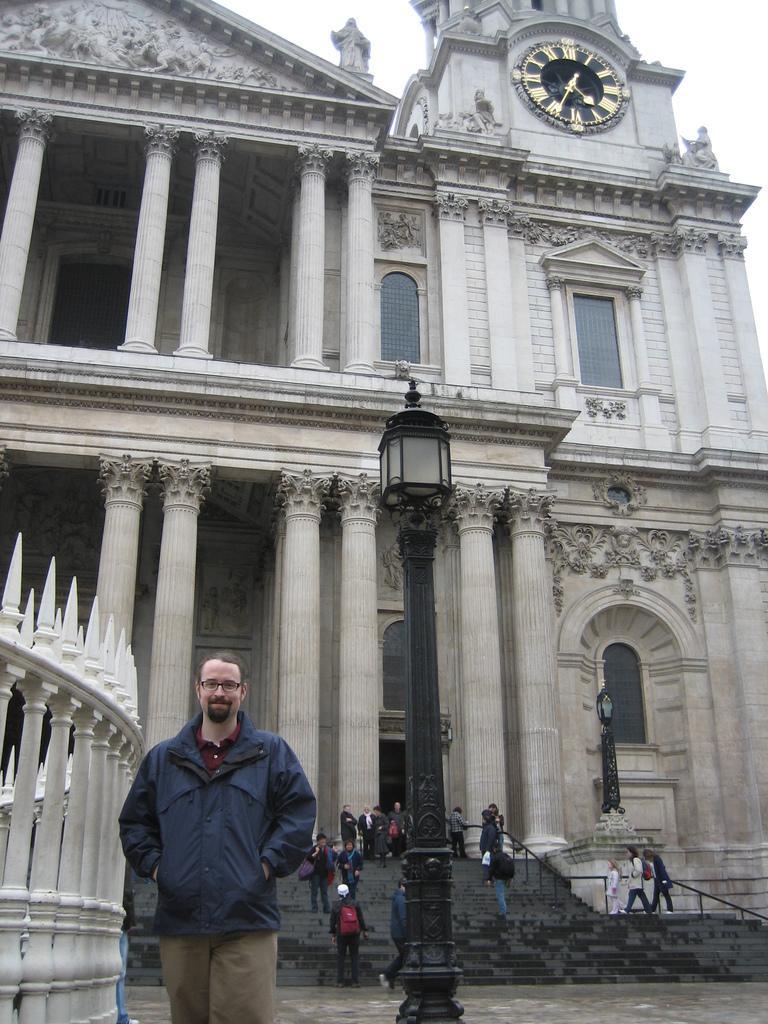How would you summarize this image in a sentence or two? In the center of the image we can see a light pole. On the left side of the image there is a person standing at the fencing. In the background there is a building, stairs, a group of persons and sky. 